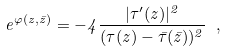Convert formula to latex. <formula><loc_0><loc_0><loc_500><loc_500>e ^ { \varphi ( z , \bar { z } ) } = - 4 \frac { | { \tau ^ { \prime } ( z ) } | ^ { 2 } } { ( \tau ( z ) - \bar { \tau } ( \bar { z } ) ) ^ { 2 } } \ ,</formula> 